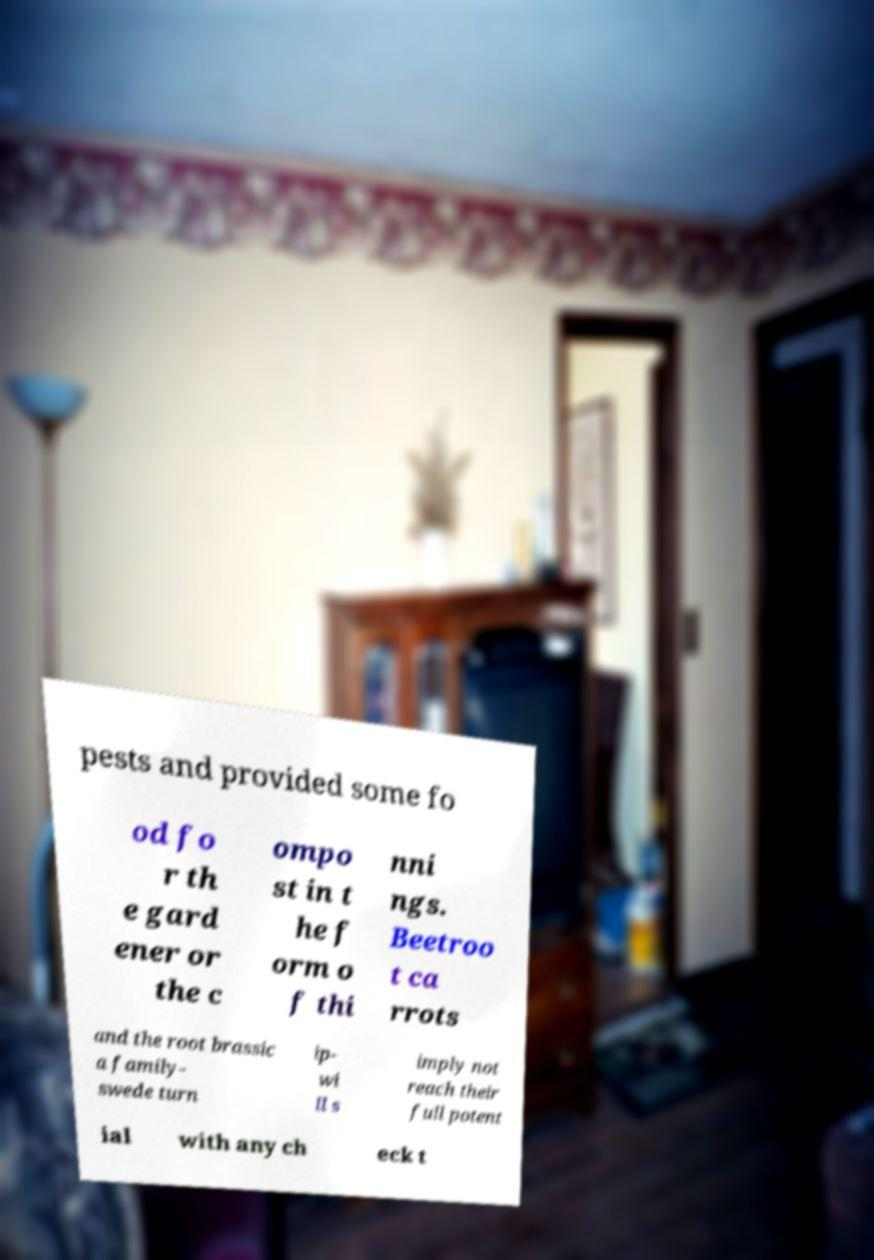For documentation purposes, I need the text within this image transcribed. Could you provide that? pests and provided some fo od fo r th e gard ener or the c ompo st in t he f orm o f thi nni ngs. Beetroo t ca rrots and the root brassic a family- swede turn ip- wi ll s imply not reach their full potent ial with any ch eck t 